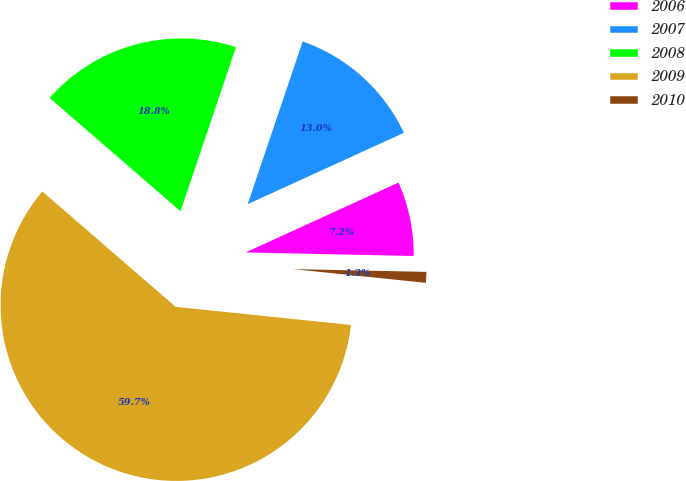Convert chart to OTSL. <chart><loc_0><loc_0><loc_500><loc_500><pie_chart><fcel>2006<fcel>2007<fcel>2008<fcel>2009<fcel>2010<nl><fcel>7.15%<fcel>12.99%<fcel>18.83%<fcel>59.71%<fcel>1.31%<nl></chart> 